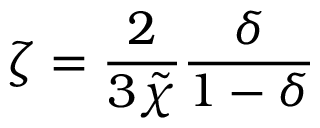Convert formula to latex. <formula><loc_0><loc_0><loc_500><loc_500>\zeta = \frac { 2 } { 3 \tilde { \chi } } \frac { \delta } { 1 - \delta }</formula> 